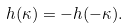<formula> <loc_0><loc_0><loc_500><loc_500>h ( \kappa ) = - h ( - \kappa ) .</formula> 